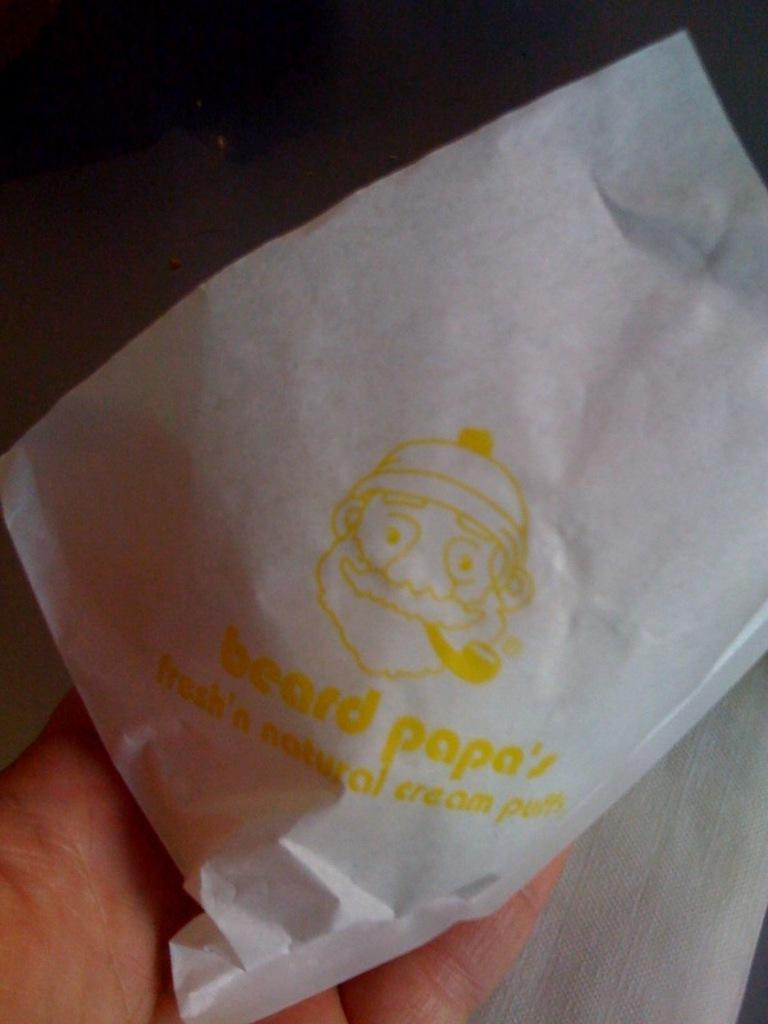What is the hand holding in the picture? The hand is holding a tissue paper in the picture. What is written on the tissue paper? "Beard Papa's" is written on the tissue paper in yellow color. What color is the top part of the image? The top part of the image is black in color. Can you see any veins in the hand holding the tissue paper? There is no mention of veins in the image, so we cannot determine if they are visible or not. 